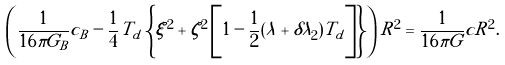Convert formula to latex. <formula><loc_0><loc_0><loc_500><loc_500>\left ( \frac { 1 } { 1 6 \pi G _ { B } } c _ { B } - \frac { 1 } { 4 } T _ { d } \left \{ \xi ^ { 2 } + \zeta ^ { 2 } \left [ 1 - \frac { 1 } { 2 } ( \lambda + \delta \lambda _ { 2 } ) T _ { d } \right ] \right \} \right ) R ^ { 2 } = \frac { 1 } { 1 6 \pi G } c R ^ { 2 } .</formula> 